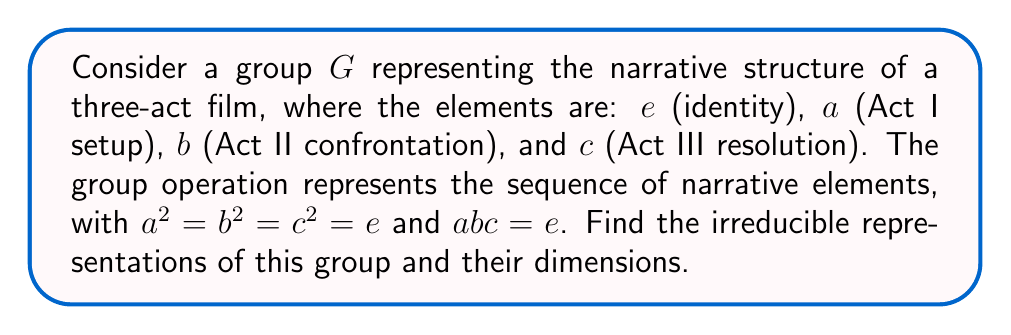Teach me how to tackle this problem. 1) First, we need to determine the conjugacy classes of the group:
   $\{e\}$, $\{a\}$, $\{b\}$, $\{c\}$

2) The number of irreducible representations is equal to the number of conjugacy classes, so we have 4 irreducible representations.

3) Let's call these representations $\rho_1, \rho_2, \rho_3, \rho_4$.

4) The sum of the squares of the dimensions of these representations must equal the order of the group:
   $$\sum_{i=1}^4 (\dim \rho_i)^2 = |G| = 4$$

5) Given that $G$ is non-abelian (since $ab \neq ba$), we know that not all representations can be 1-dimensional.

6) The only solution that satisfies this is: three 1-dimensional representations and one 2-dimensional representation.

7) For the 1-dimensional representations:
   $\rho_1(g) = 1$ for all $g \in G$ (the trivial representation)
   $\rho_2(a) = 1, \rho_2(b) = -1, \rho_2(c) = -1$
   $\rho_3(a) = -1, \rho_2(b) = 1, \rho_2(c) = -1$

8) For the 2-dimensional representation $\rho_4$, we can use the fact that $a^2 = b^2 = c^2 = e$ and $abc = e$:
   $$\rho_4(a) = \begin{pmatrix} 0 & 1 \\ 1 & 0 \end{pmatrix},
     \rho_4(b) = \begin{pmatrix} -1 & 0 \\ 0 & 1 \end{pmatrix},
     \rho_4(c) = \begin{pmatrix} 0 & -1 \\ 1 & 0 \end{pmatrix}$$

   These matrices satisfy the group relations and form an irreducible representation.
Answer: Three 1-dimensional representations and one 2-dimensional representation. 